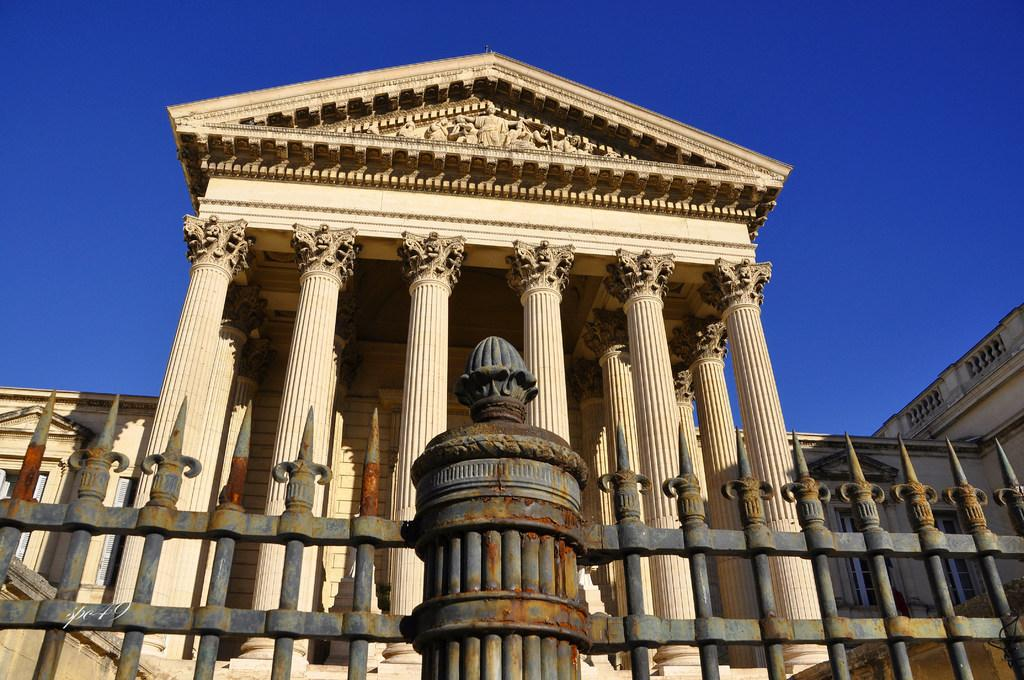What architectural features can be seen in the image? There are pillars, a fence, and a wall visible in the image. What is located at the top of the image? There are statues visible at the top of the image. What is visible in the background of the image? The sky is visible at the top of the image. Can you describe the woman's back in the image? There is no woman present in the image, so it is not possible to describe her back. 